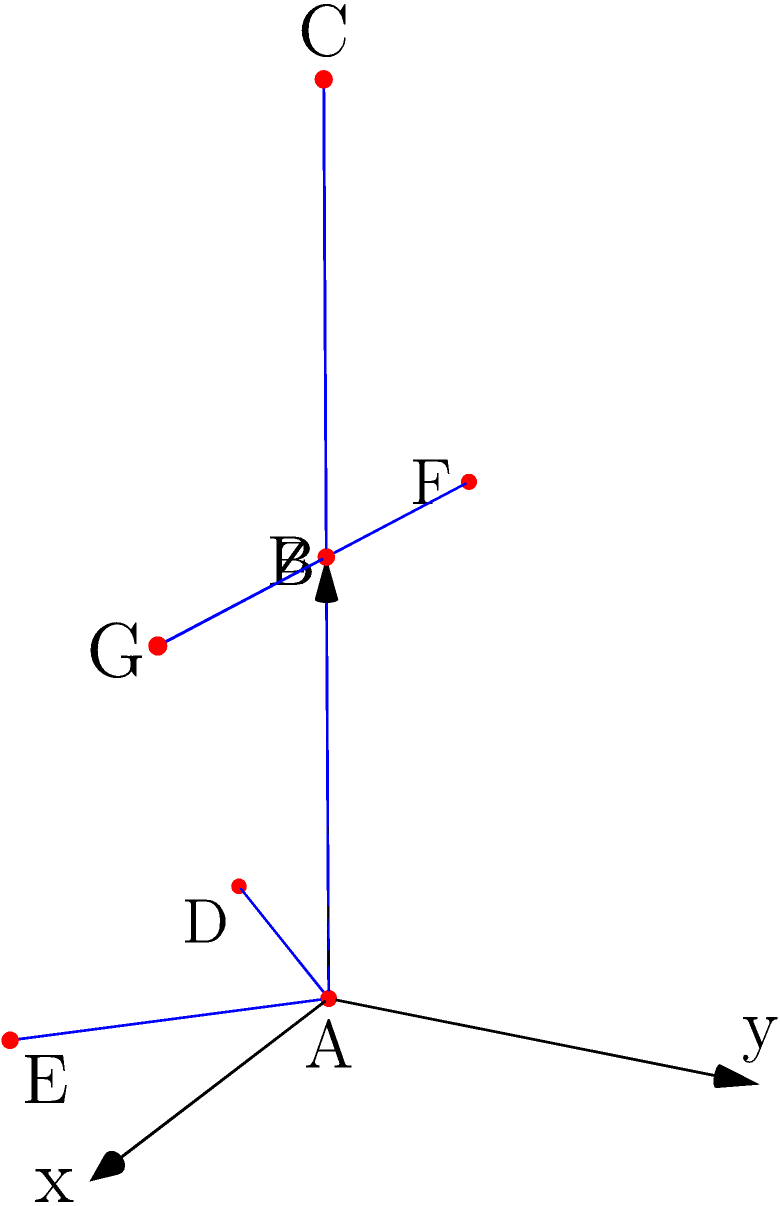In a 3D game character model, the center of mass is crucial for realistic physics simulations. Given the skeleton diagram above, where A represents the hip, B the torso, C the head, D and E the feet, and F and G the hands, how would you determine the center of mass if the mass distribution is as follows: hip (30%), torso (35%), head (10%), each foot (5%), and each hand (7.5%)? Assume the character is in a T-pose and the coordinates are in meters. To determine the center of mass for the 3D game character model, we need to follow these steps:

1. Identify the position and mass of each body part:
   A (hip): (0,0,0), 30%
   B (torso): (0,0,1), 35%
   C (head): (0,0,2), 10%
   D (left foot): (-0.5,-0.5,0), 5%
   E (right foot): (0.5,-0.5,0), 5%
   F (left hand): (-0.7,0,1), 7.5%
   G (right hand): (0.7,0,1), 7.5%

2. Calculate the weighted position for each body part by multiplying its position by its mass percentage:
   A: (0,0,0) * 0.30 = (0,0,0)
   B: (0,0,1) * 0.35 = (0,0,0.35)
   C: (0,0,2) * 0.10 = (0,0,0.2)
   D: (-0.5,-0.5,0) * 0.05 = (-0.025,-0.025,0)
   E: (0.5,-0.5,0) * 0.05 = (0.025,-0.025,0)
   F: (-0.7,0,1) * 0.075 = (-0.0525,0,0.075)
   G: (0.7,0,1) * 0.075 = (0.0525,0,0.075)

3. Sum up all the weighted positions:
   x = 0 + 0 + 0 + (-0.025) + 0.025 + (-0.0525) + 0.0525 = 0
   y = 0 + 0 + 0 + (-0.025) + (-0.025) + 0 + 0 = -0.05
   z = 0 + 0.35 + 0.2 + 0 + 0 + 0.075 + 0.075 = 0.7

4. The resulting sum (0, -0.05, 0.7) represents the center of mass of the character model.

In the context of game development and quality assurance, this calculation ensures that physics-based animations and interactions are realistic and consistent with the character's modeled mass distribution.
Answer: $(0, -0.05, 0.7)$ meters 